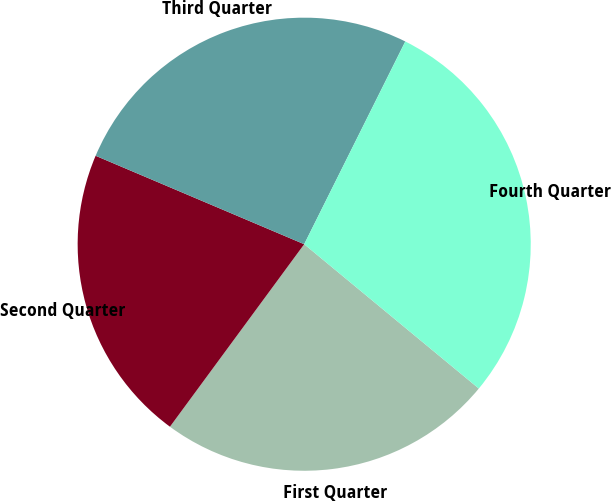<chart> <loc_0><loc_0><loc_500><loc_500><pie_chart><fcel>First Quarter<fcel>Second Quarter<fcel>Third Quarter<fcel>Fourth Quarter<nl><fcel>24.1%<fcel>21.29%<fcel>25.98%<fcel>28.63%<nl></chart> 